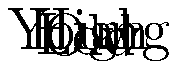In the 3D representation of voter turnout percentages across different demographics, what pattern is observed in relation to age and income levels? How might this information be used to critically analyze claims about voter participation and potential fraud? To interpret this 3D representation and analyze its implications:

1. Observe the axes:
   - X-axis represents age (from young to old)
   - Y-axis represents income (from low to high)
   - Z-axis represents voter turnout percentage

2. Analyze the surface pattern:
   - The peak of the surface is near the center-right, indicating higher turnout for older, middle-to-high income voters
   - The surface slopes down towards younger ages and lower incomes, showing lower turnout in these demographics

3. Consider the implications:
   - Voter turnout is not uniform across demographics
   - Age and income appear to be significant factors in voter participation
   - The highest turnout is among older, middle-to-high income voters

4. Critical analysis of fraud claims:
   - This data shows expected patterns based on historical trends and sociological factors
   - Lower turnout among younger and lower-income voters is consistent with known barriers to voting (e.g., work schedules, transportation issues)
   - Higher turnout among older, more affluent voters aligns with their typically higher civic engagement

5. Addressing fraud allegations:
   - Variations in turnout across demographics are normal and don't indicate fraud
   - Claims of fraud often ignore these demographic patterns
   - Understanding these patterns helps debunk unfounded fraud allegations

6. Journalistic approach:
   - Use this data to contextualize turnout numbers in reporting
   - Question claims that don't account for demographic variations
   - Emphasize the importance of understanding voter behavior patterns in election analysis
Answer: Voter turnout increases with age and income; this pattern reflects known demographic trends rather than evidence of fraud. 